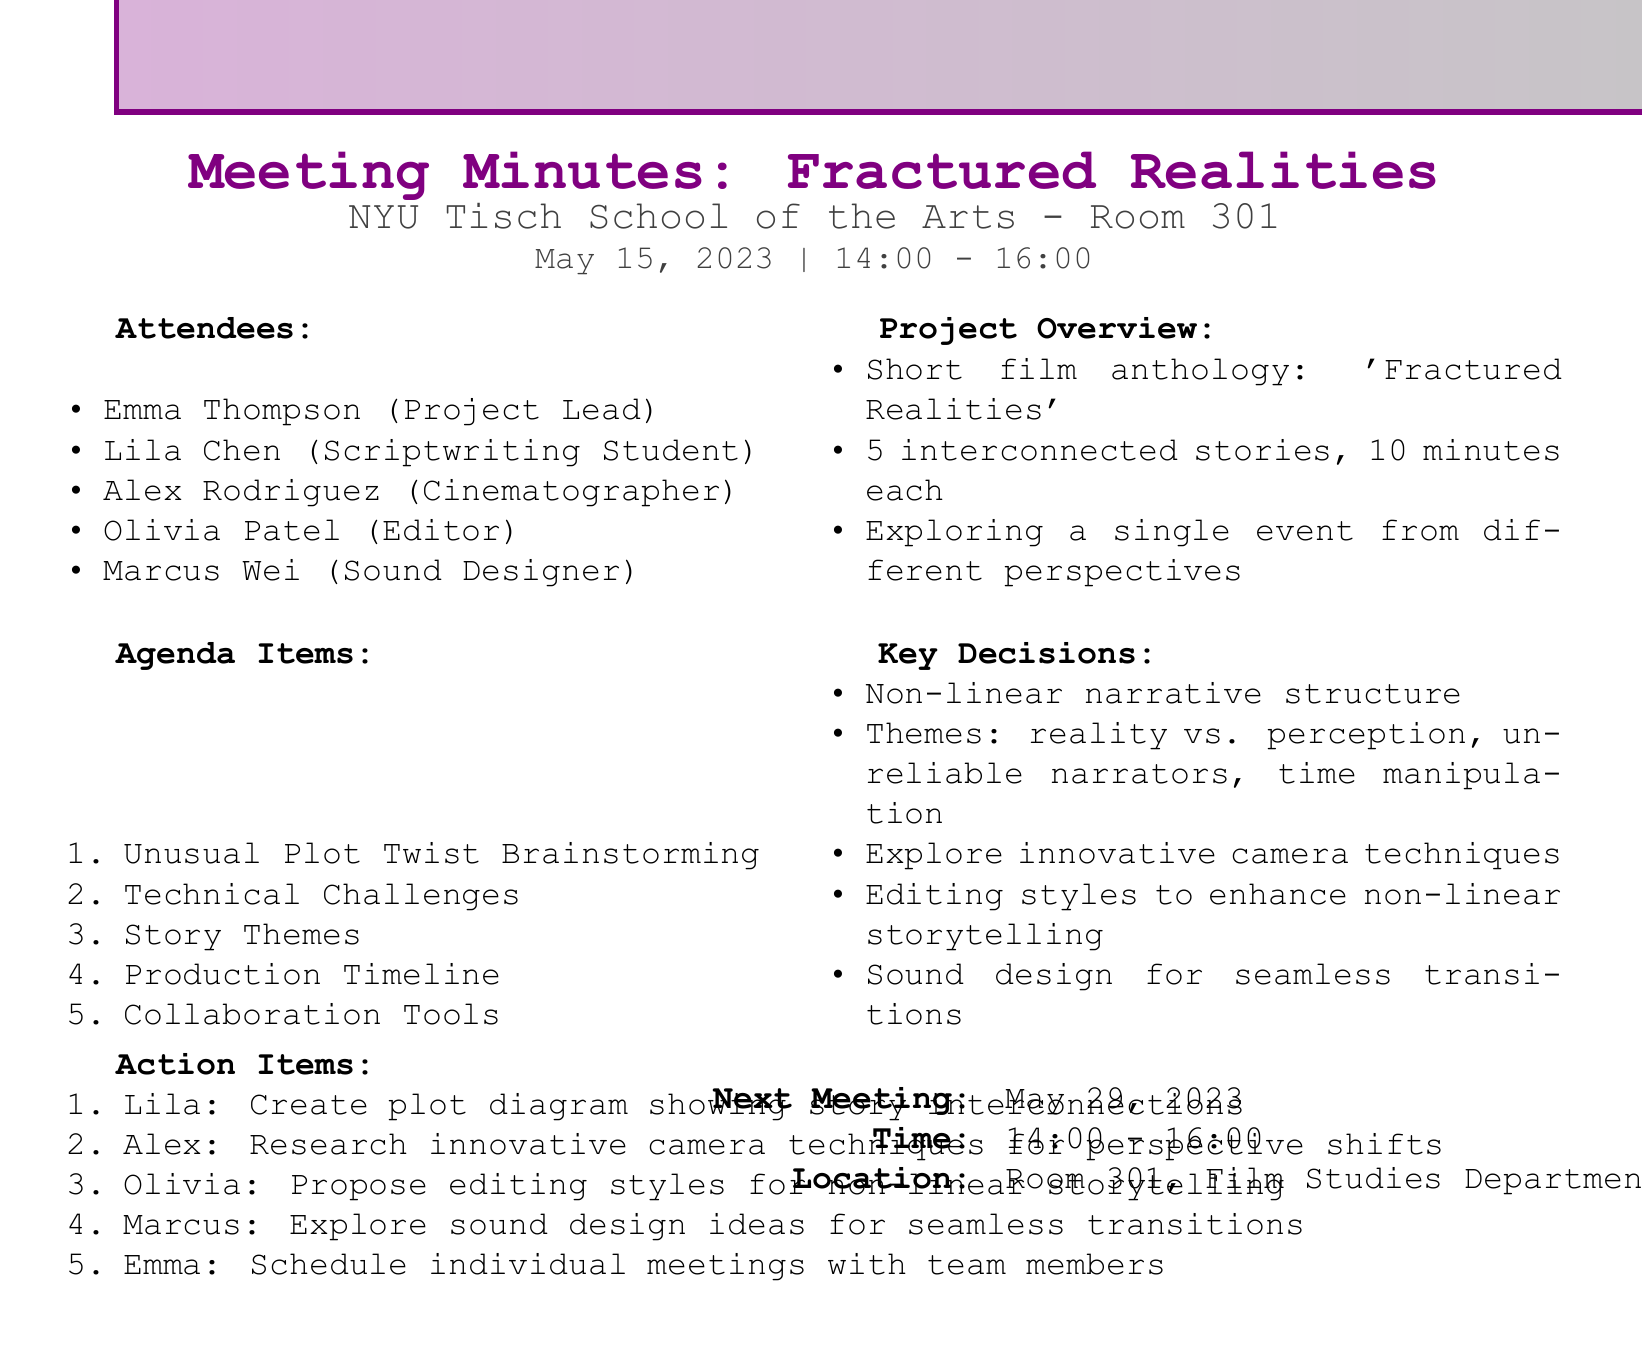What is the title of the short film anthology? The title of the short film anthology is mentioned in the project overview section of the document.
Answer: Fractured Realities Who is the project lead? The project lead is listed among the attendees in the document.
Answer: Emma Thompson How many interconnected stories are planned for the anthology? The number of interconnected stories planned is specified in the project overview.
Answer: 5 What date is the next meeting scheduled for? The date for the next meeting is mentioned at the end of the document.
Answer: May 29, 2023 What action item is assigned to Lila? The action items list specifies what each team member is responsible for, including Lila.
Answer: Create plot diagram showing story interconnections Which themes are decided for the film anthology? The document provides a list of overarching themes decided during the meeting.
Answer: reality vs. perception, unreliable narrators, time manipulation What time does the meeting start? The start time of the meeting is indicated in the meeting information section.
Answer: 14:00 What are the collaboration tools mentioned? The tools discussed for collaboration are listed in the agenda items.
Answer: Final Draft, Celtx, or WriterDuet What is the role of Olivia in the project? Olivia's role is provided in the attendees list of the document.
Answer: Editor 